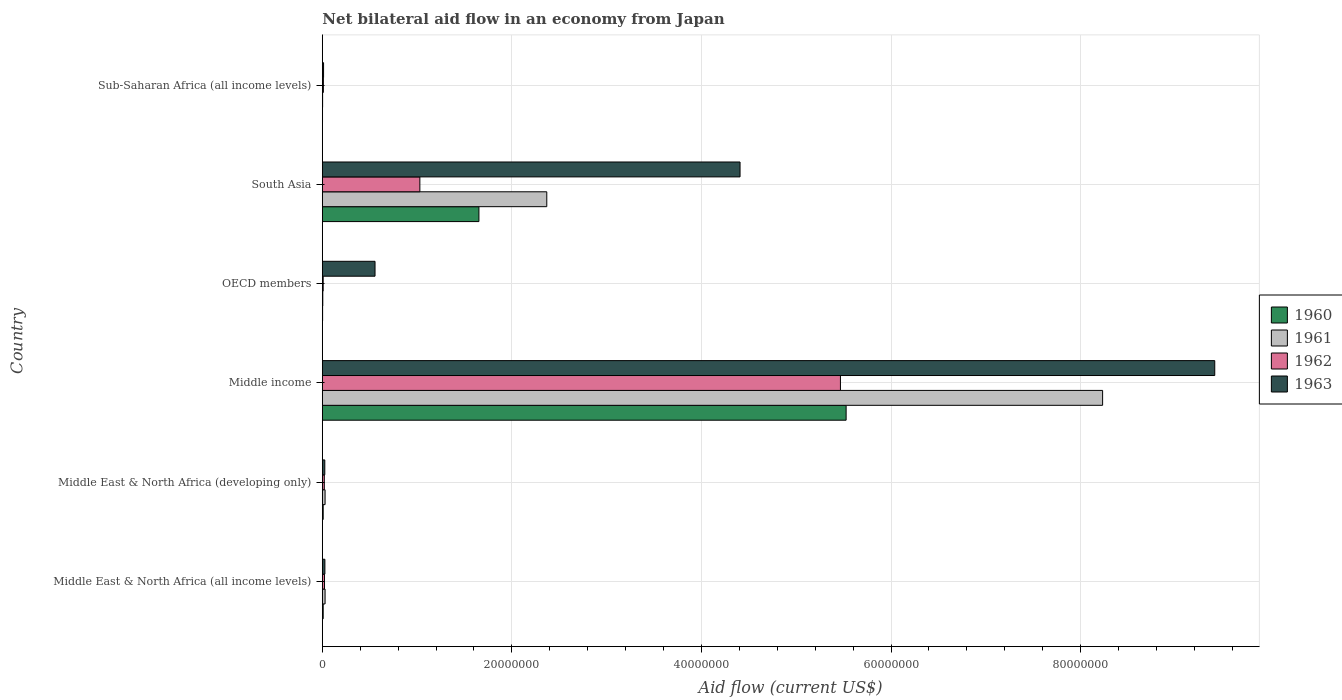How many different coloured bars are there?
Ensure brevity in your answer.  4. Are the number of bars per tick equal to the number of legend labels?
Your answer should be very brief. Yes. How many bars are there on the 6th tick from the top?
Ensure brevity in your answer.  4. How many bars are there on the 5th tick from the bottom?
Provide a short and direct response. 4. What is the net bilateral aid flow in 1963 in Middle East & North Africa (all income levels)?
Ensure brevity in your answer.  2.70e+05. Across all countries, what is the maximum net bilateral aid flow in 1962?
Provide a short and direct response. 5.47e+07. Across all countries, what is the minimum net bilateral aid flow in 1962?
Offer a very short reply. 9.00e+04. In which country was the net bilateral aid flow in 1960 minimum?
Offer a terse response. Sub-Saharan Africa (all income levels). What is the total net bilateral aid flow in 1960 in the graph?
Ensure brevity in your answer.  7.20e+07. What is the difference between the net bilateral aid flow in 1961 in South Asia and the net bilateral aid flow in 1960 in Middle East & North Africa (developing only)?
Offer a terse response. 2.36e+07. What is the average net bilateral aid flow in 1963 per country?
Provide a short and direct response. 2.41e+07. What is the difference between the net bilateral aid flow in 1961 and net bilateral aid flow in 1962 in South Asia?
Ensure brevity in your answer.  1.34e+07. In how many countries, is the net bilateral aid flow in 1960 greater than 92000000 US$?
Make the answer very short. 0. What is the ratio of the net bilateral aid flow in 1961 in Middle East & North Africa (developing only) to that in Middle income?
Provide a succinct answer. 0. Is the net bilateral aid flow in 1961 in OECD members less than that in Sub-Saharan Africa (all income levels)?
Offer a terse response. No. Is the difference between the net bilateral aid flow in 1961 in OECD members and Sub-Saharan Africa (all income levels) greater than the difference between the net bilateral aid flow in 1962 in OECD members and Sub-Saharan Africa (all income levels)?
Keep it short and to the point. Yes. What is the difference between the highest and the second highest net bilateral aid flow in 1960?
Offer a terse response. 3.87e+07. What is the difference between the highest and the lowest net bilateral aid flow in 1961?
Keep it short and to the point. 8.23e+07. In how many countries, is the net bilateral aid flow in 1963 greater than the average net bilateral aid flow in 1963 taken over all countries?
Your answer should be very brief. 2. Is the sum of the net bilateral aid flow in 1963 in Middle East & North Africa (all income levels) and Middle income greater than the maximum net bilateral aid flow in 1960 across all countries?
Offer a terse response. Yes. Is it the case that in every country, the sum of the net bilateral aid flow in 1960 and net bilateral aid flow in 1963 is greater than the sum of net bilateral aid flow in 1961 and net bilateral aid flow in 1962?
Your answer should be compact. No. What does the 2nd bar from the top in Middle East & North Africa (developing only) represents?
Keep it short and to the point. 1962. What does the 4th bar from the bottom in Middle income represents?
Offer a very short reply. 1963. How many bars are there?
Your answer should be very brief. 24. How many countries are there in the graph?
Offer a very short reply. 6. Does the graph contain grids?
Provide a succinct answer. Yes. Where does the legend appear in the graph?
Offer a terse response. Center right. How are the legend labels stacked?
Offer a terse response. Vertical. What is the title of the graph?
Offer a very short reply. Net bilateral aid flow in an economy from Japan. Does "2011" appear as one of the legend labels in the graph?
Your response must be concise. No. What is the Aid flow (current US$) of 1962 in Middle East & North Africa (all income levels)?
Provide a short and direct response. 2.30e+05. What is the Aid flow (current US$) of 1963 in Middle East & North Africa (all income levels)?
Give a very brief answer. 2.70e+05. What is the Aid flow (current US$) in 1961 in Middle East & North Africa (developing only)?
Keep it short and to the point. 2.90e+05. What is the Aid flow (current US$) in 1962 in Middle East & North Africa (developing only)?
Keep it short and to the point. 2.10e+05. What is the Aid flow (current US$) of 1963 in Middle East & North Africa (developing only)?
Provide a succinct answer. 2.60e+05. What is the Aid flow (current US$) in 1960 in Middle income?
Provide a short and direct response. 5.53e+07. What is the Aid flow (current US$) in 1961 in Middle income?
Your answer should be compact. 8.23e+07. What is the Aid flow (current US$) of 1962 in Middle income?
Provide a succinct answer. 5.47e+07. What is the Aid flow (current US$) of 1963 in Middle income?
Offer a terse response. 9.42e+07. What is the Aid flow (current US$) in 1960 in OECD members?
Offer a very short reply. 3.00e+04. What is the Aid flow (current US$) in 1962 in OECD members?
Give a very brief answer. 9.00e+04. What is the Aid flow (current US$) of 1963 in OECD members?
Offer a terse response. 5.56e+06. What is the Aid flow (current US$) of 1960 in South Asia?
Provide a succinct answer. 1.65e+07. What is the Aid flow (current US$) in 1961 in South Asia?
Your answer should be compact. 2.37e+07. What is the Aid flow (current US$) of 1962 in South Asia?
Provide a succinct answer. 1.03e+07. What is the Aid flow (current US$) in 1963 in South Asia?
Your answer should be compact. 4.41e+07. What is the Aid flow (current US$) of 1961 in Sub-Saharan Africa (all income levels)?
Your response must be concise. 3.00e+04. What is the Aid flow (current US$) of 1962 in Sub-Saharan Africa (all income levels)?
Your response must be concise. 1.10e+05. What is the Aid flow (current US$) in 1963 in Sub-Saharan Africa (all income levels)?
Keep it short and to the point. 1.30e+05. Across all countries, what is the maximum Aid flow (current US$) of 1960?
Your response must be concise. 5.53e+07. Across all countries, what is the maximum Aid flow (current US$) of 1961?
Make the answer very short. 8.23e+07. Across all countries, what is the maximum Aid flow (current US$) in 1962?
Your response must be concise. 5.47e+07. Across all countries, what is the maximum Aid flow (current US$) of 1963?
Your response must be concise. 9.42e+07. Across all countries, what is the minimum Aid flow (current US$) in 1961?
Keep it short and to the point. 3.00e+04. Across all countries, what is the minimum Aid flow (current US$) of 1962?
Ensure brevity in your answer.  9.00e+04. Across all countries, what is the minimum Aid flow (current US$) in 1963?
Give a very brief answer. 1.30e+05. What is the total Aid flow (current US$) of 1960 in the graph?
Your answer should be very brief. 7.20e+07. What is the total Aid flow (current US$) of 1961 in the graph?
Give a very brief answer. 1.07e+08. What is the total Aid flow (current US$) of 1962 in the graph?
Offer a very short reply. 6.56e+07. What is the total Aid flow (current US$) in 1963 in the graph?
Your answer should be very brief. 1.44e+08. What is the difference between the Aid flow (current US$) in 1961 in Middle East & North Africa (all income levels) and that in Middle East & North Africa (developing only)?
Ensure brevity in your answer.  0. What is the difference between the Aid flow (current US$) in 1962 in Middle East & North Africa (all income levels) and that in Middle East & North Africa (developing only)?
Give a very brief answer. 2.00e+04. What is the difference between the Aid flow (current US$) in 1960 in Middle East & North Africa (all income levels) and that in Middle income?
Provide a short and direct response. -5.52e+07. What is the difference between the Aid flow (current US$) in 1961 in Middle East & North Africa (all income levels) and that in Middle income?
Offer a very short reply. -8.20e+07. What is the difference between the Aid flow (current US$) of 1962 in Middle East & North Africa (all income levels) and that in Middle income?
Provide a succinct answer. -5.44e+07. What is the difference between the Aid flow (current US$) of 1963 in Middle East & North Africa (all income levels) and that in Middle income?
Keep it short and to the point. -9.39e+07. What is the difference between the Aid flow (current US$) in 1962 in Middle East & North Africa (all income levels) and that in OECD members?
Provide a short and direct response. 1.40e+05. What is the difference between the Aid flow (current US$) in 1963 in Middle East & North Africa (all income levels) and that in OECD members?
Your response must be concise. -5.29e+06. What is the difference between the Aid flow (current US$) in 1960 in Middle East & North Africa (all income levels) and that in South Asia?
Offer a terse response. -1.64e+07. What is the difference between the Aid flow (current US$) of 1961 in Middle East & North Africa (all income levels) and that in South Asia?
Offer a terse response. -2.34e+07. What is the difference between the Aid flow (current US$) in 1962 in Middle East & North Africa (all income levels) and that in South Asia?
Offer a very short reply. -1.01e+07. What is the difference between the Aid flow (current US$) in 1963 in Middle East & North Africa (all income levels) and that in South Asia?
Offer a very short reply. -4.38e+07. What is the difference between the Aid flow (current US$) in 1961 in Middle East & North Africa (all income levels) and that in Sub-Saharan Africa (all income levels)?
Ensure brevity in your answer.  2.60e+05. What is the difference between the Aid flow (current US$) in 1963 in Middle East & North Africa (all income levels) and that in Sub-Saharan Africa (all income levels)?
Keep it short and to the point. 1.40e+05. What is the difference between the Aid flow (current US$) of 1960 in Middle East & North Africa (developing only) and that in Middle income?
Your answer should be compact. -5.52e+07. What is the difference between the Aid flow (current US$) in 1961 in Middle East & North Africa (developing only) and that in Middle income?
Your response must be concise. -8.20e+07. What is the difference between the Aid flow (current US$) of 1962 in Middle East & North Africa (developing only) and that in Middle income?
Your answer should be very brief. -5.44e+07. What is the difference between the Aid flow (current US$) of 1963 in Middle East & North Africa (developing only) and that in Middle income?
Give a very brief answer. -9.39e+07. What is the difference between the Aid flow (current US$) in 1960 in Middle East & North Africa (developing only) and that in OECD members?
Keep it short and to the point. 6.00e+04. What is the difference between the Aid flow (current US$) in 1961 in Middle East & North Africa (developing only) and that in OECD members?
Your response must be concise. 2.40e+05. What is the difference between the Aid flow (current US$) in 1962 in Middle East & North Africa (developing only) and that in OECD members?
Your answer should be very brief. 1.20e+05. What is the difference between the Aid flow (current US$) in 1963 in Middle East & North Africa (developing only) and that in OECD members?
Provide a succinct answer. -5.30e+06. What is the difference between the Aid flow (current US$) in 1960 in Middle East & North Africa (developing only) and that in South Asia?
Make the answer very short. -1.64e+07. What is the difference between the Aid flow (current US$) of 1961 in Middle East & North Africa (developing only) and that in South Asia?
Your response must be concise. -2.34e+07. What is the difference between the Aid flow (current US$) of 1962 in Middle East & North Africa (developing only) and that in South Asia?
Your answer should be very brief. -1.01e+07. What is the difference between the Aid flow (current US$) of 1963 in Middle East & North Africa (developing only) and that in South Asia?
Provide a succinct answer. -4.38e+07. What is the difference between the Aid flow (current US$) of 1961 in Middle East & North Africa (developing only) and that in Sub-Saharan Africa (all income levels)?
Your response must be concise. 2.60e+05. What is the difference between the Aid flow (current US$) of 1962 in Middle East & North Africa (developing only) and that in Sub-Saharan Africa (all income levels)?
Your answer should be very brief. 1.00e+05. What is the difference between the Aid flow (current US$) of 1960 in Middle income and that in OECD members?
Your response must be concise. 5.52e+07. What is the difference between the Aid flow (current US$) of 1961 in Middle income and that in OECD members?
Ensure brevity in your answer.  8.23e+07. What is the difference between the Aid flow (current US$) of 1962 in Middle income and that in OECD members?
Keep it short and to the point. 5.46e+07. What is the difference between the Aid flow (current US$) in 1963 in Middle income and that in OECD members?
Keep it short and to the point. 8.86e+07. What is the difference between the Aid flow (current US$) of 1960 in Middle income and that in South Asia?
Ensure brevity in your answer.  3.87e+07. What is the difference between the Aid flow (current US$) in 1961 in Middle income and that in South Asia?
Ensure brevity in your answer.  5.86e+07. What is the difference between the Aid flow (current US$) of 1962 in Middle income and that in South Asia?
Provide a short and direct response. 4.44e+07. What is the difference between the Aid flow (current US$) in 1963 in Middle income and that in South Asia?
Your answer should be compact. 5.01e+07. What is the difference between the Aid flow (current US$) in 1960 in Middle income and that in Sub-Saharan Africa (all income levels)?
Your response must be concise. 5.52e+07. What is the difference between the Aid flow (current US$) in 1961 in Middle income and that in Sub-Saharan Africa (all income levels)?
Ensure brevity in your answer.  8.23e+07. What is the difference between the Aid flow (current US$) in 1962 in Middle income and that in Sub-Saharan Africa (all income levels)?
Offer a terse response. 5.46e+07. What is the difference between the Aid flow (current US$) of 1963 in Middle income and that in Sub-Saharan Africa (all income levels)?
Offer a terse response. 9.40e+07. What is the difference between the Aid flow (current US$) in 1960 in OECD members and that in South Asia?
Provide a short and direct response. -1.65e+07. What is the difference between the Aid flow (current US$) of 1961 in OECD members and that in South Asia?
Ensure brevity in your answer.  -2.36e+07. What is the difference between the Aid flow (current US$) in 1962 in OECD members and that in South Asia?
Your answer should be very brief. -1.02e+07. What is the difference between the Aid flow (current US$) of 1963 in OECD members and that in South Asia?
Provide a short and direct response. -3.85e+07. What is the difference between the Aid flow (current US$) in 1960 in OECD members and that in Sub-Saharan Africa (all income levels)?
Ensure brevity in your answer.  10000. What is the difference between the Aid flow (current US$) in 1961 in OECD members and that in Sub-Saharan Africa (all income levels)?
Ensure brevity in your answer.  2.00e+04. What is the difference between the Aid flow (current US$) of 1962 in OECD members and that in Sub-Saharan Africa (all income levels)?
Make the answer very short. -2.00e+04. What is the difference between the Aid flow (current US$) in 1963 in OECD members and that in Sub-Saharan Africa (all income levels)?
Provide a short and direct response. 5.43e+06. What is the difference between the Aid flow (current US$) of 1960 in South Asia and that in Sub-Saharan Africa (all income levels)?
Provide a succinct answer. 1.65e+07. What is the difference between the Aid flow (current US$) of 1961 in South Asia and that in Sub-Saharan Africa (all income levels)?
Your answer should be very brief. 2.36e+07. What is the difference between the Aid flow (current US$) of 1962 in South Asia and that in Sub-Saharan Africa (all income levels)?
Provide a succinct answer. 1.02e+07. What is the difference between the Aid flow (current US$) in 1963 in South Asia and that in Sub-Saharan Africa (all income levels)?
Your answer should be compact. 4.39e+07. What is the difference between the Aid flow (current US$) of 1960 in Middle East & North Africa (all income levels) and the Aid flow (current US$) of 1961 in Middle East & North Africa (developing only)?
Ensure brevity in your answer.  -2.00e+05. What is the difference between the Aid flow (current US$) of 1960 in Middle East & North Africa (all income levels) and the Aid flow (current US$) of 1962 in Middle East & North Africa (developing only)?
Your answer should be compact. -1.20e+05. What is the difference between the Aid flow (current US$) of 1961 in Middle East & North Africa (all income levels) and the Aid flow (current US$) of 1962 in Middle East & North Africa (developing only)?
Offer a very short reply. 8.00e+04. What is the difference between the Aid flow (current US$) of 1960 in Middle East & North Africa (all income levels) and the Aid flow (current US$) of 1961 in Middle income?
Keep it short and to the point. -8.22e+07. What is the difference between the Aid flow (current US$) in 1960 in Middle East & North Africa (all income levels) and the Aid flow (current US$) in 1962 in Middle income?
Offer a terse response. -5.46e+07. What is the difference between the Aid flow (current US$) in 1960 in Middle East & North Africa (all income levels) and the Aid flow (current US$) in 1963 in Middle income?
Provide a short and direct response. -9.41e+07. What is the difference between the Aid flow (current US$) in 1961 in Middle East & North Africa (all income levels) and the Aid flow (current US$) in 1962 in Middle income?
Your answer should be compact. -5.44e+07. What is the difference between the Aid flow (current US$) in 1961 in Middle East & North Africa (all income levels) and the Aid flow (current US$) in 1963 in Middle income?
Your response must be concise. -9.39e+07. What is the difference between the Aid flow (current US$) in 1962 in Middle East & North Africa (all income levels) and the Aid flow (current US$) in 1963 in Middle income?
Offer a terse response. -9.39e+07. What is the difference between the Aid flow (current US$) of 1960 in Middle East & North Africa (all income levels) and the Aid flow (current US$) of 1961 in OECD members?
Your answer should be compact. 4.00e+04. What is the difference between the Aid flow (current US$) of 1960 in Middle East & North Africa (all income levels) and the Aid flow (current US$) of 1962 in OECD members?
Your answer should be compact. 0. What is the difference between the Aid flow (current US$) in 1960 in Middle East & North Africa (all income levels) and the Aid flow (current US$) in 1963 in OECD members?
Your response must be concise. -5.47e+06. What is the difference between the Aid flow (current US$) in 1961 in Middle East & North Africa (all income levels) and the Aid flow (current US$) in 1963 in OECD members?
Provide a succinct answer. -5.27e+06. What is the difference between the Aid flow (current US$) in 1962 in Middle East & North Africa (all income levels) and the Aid flow (current US$) in 1963 in OECD members?
Provide a short and direct response. -5.33e+06. What is the difference between the Aid flow (current US$) of 1960 in Middle East & North Africa (all income levels) and the Aid flow (current US$) of 1961 in South Asia?
Provide a short and direct response. -2.36e+07. What is the difference between the Aid flow (current US$) in 1960 in Middle East & North Africa (all income levels) and the Aid flow (current US$) in 1962 in South Asia?
Provide a succinct answer. -1.02e+07. What is the difference between the Aid flow (current US$) in 1960 in Middle East & North Africa (all income levels) and the Aid flow (current US$) in 1963 in South Asia?
Offer a terse response. -4.40e+07. What is the difference between the Aid flow (current US$) in 1961 in Middle East & North Africa (all income levels) and the Aid flow (current US$) in 1962 in South Asia?
Ensure brevity in your answer.  -1.00e+07. What is the difference between the Aid flow (current US$) of 1961 in Middle East & North Africa (all income levels) and the Aid flow (current US$) of 1963 in South Asia?
Your answer should be compact. -4.38e+07. What is the difference between the Aid flow (current US$) in 1962 in Middle East & North Africa (all income levels) and the Aid flow (current US$) in 1963 in South Asia?
Give a very brief answer. -4.38e+07. What is the difference between the Aid flow (current US$) in 1960 in Middle East & North Africa (all income levels) and the Aid flow (current US$) in 1962 in Sub-Saharan Africa (all income levels)?
Offer a terse response. -2.00e+04. What is the difference between the Aid flow (current US$) of 1960 in Middle East & North Africa (developing only) and the Aid flow (current US$) of 1961 in Middle income?
Provide a succinct answer. -8.22e+07. What is the difference between the Aid flow (current US$) of 1960 in Middle East & North Africa (developing only) and the Aid flow (current US$) of 1962 in Middle income?
Keep it short and to the point. -5.46e+07. What is the difference between the Aid flow (current US$) of 1960 in Middle East & North Africa (developing only) and the Aid flow (current US$) of 1963 in Middle income?
Offer a terse response. -9.41e+07. What is the difference between the Aid flow (current US$) in 1961 in Middle East & North Africa (developing only) and the Aid flow (current US$) in 1962 in Middle income?
Make the answer very short. -5.44e+07. What is the difference between the Aid flow (current US$) in 1961 in Middle East & North Africa (developing only) and the Aid flow (current US$) in 1963 in Middle income?
Give a very brief answer. -9.39e+07. What is the difference between the Aid flow (current US$) of 1962 in Middle East & North Africa (developing only) and the Aid flow (current US$) of 1963 in Middle income?
Your response must be concise. -9.39e+07. What is the difference between the Aid flow (current US$) of 1960 in Middle East & North Africa (developing only) and the Aid flow (current US$) of 1962 in OECD members?
Give a very brief answer. 0. What is the difference between the Aid flow (current US$) in 1960 in Middle East & North Africa (developing only) and the Aid flow (current US$) in 1963 in OECD members?
Give a very brief answer. -5.47e+06. What is the difference between the Aid flow (current US$) in 1961 in Middle East & North Africa (developing only) and the Aid flow (current US$) in 1963 in OECD members?
Ensure brevity in your answer.  -5.27e+06. What is the difference between the Aid flow (current US$) in 1962 in Middle East & North Africa (developing only) and the Aid flow (current US$) in 1963 in OECD members?
Give a very brief answer. -5.35e+06. What is the difference between the Aid flow (current US$) of 1960 in Middle East & North Africa (developing only) and the Aid flow (current US$) of 1961 in South Asia?
Your response must be concise. -2.36e+07. What is the difference between the Aid flow (current US$) of 1960 in Middle East & North Africa (developing only) and the Aid flow (current US$) of 1962 in South Asia?
Ensure brevity in your answer.  -1.02e+07. What is the difference between the Aid flow (current US$) of 1960 in Middle East & North Africa (developing only) and the Aid flow (current US$) of 1963 in South Asia?
Ensure brevity in your answer.  -4.40e+07. What is the difference between the Aid flow (current US$) in 1961 in Middle East & North Africa (developing only) and the Aid flow (current US$) in 1962 in South Asia?
Offer a terse response. -1.00e+07. What is the difference between the Aid flow (current US$) in 1961 in Middle East & North Africa (developing only) and the Aid flow (current US$) in 1963 in South Asia?
Ensure brevity in your answer.  -4.38e+07. What is the difference between the Aid flow (current US$) in 1962 in Middle East & North Africa (developing only) and the Aid flow (current US$) in 1963 in South Asia?
Your answer should be very brief. -4.39e+07. What is the difference between the Aid flow (current US$) of 1960 in Middle East & North Africa (developing only) and the Aid flow (current US$) of 1961 in Sub-Saharan Africa (all income levels)?
Your answer should be compact. 6.00e+04. What is the difference between the Aid flow (current US$) of 1960 in Middle East & North Africa (developing only) and the Aid flow (current US$) of 1963 in Sub-Saharan Africa (all income levels)?
Offer a terse response. -4.00e+04. What is the difference between the Aid flow (current US$) of 1961 in Middle East & North Africa (developing only) and the Aid flow (current US$) of 1962 in Sub-Saharan Africa (all income levels)?
Give a very brief answer. 1.80e+05. What is the difference between the Aid flow (current US$) in 1962 in Middle East & North Africa (developing only) and the Aid flow (current US$) in 1963 in Sub-Saharan Africa (all income levels)?
Your answer should be very brief. 8.00e+04. What is the difference between the Aid flow (current US$) in 1960 in Middle income and the Aid flow (current US$) in 1961 in OECD members?
Give a very brief answer. 5.52e+07. What is the difference between the Aid flow (current US$) of 1960 in Middle income and the Aid flow (current US$) of 1962 in OECD members?
Offer a terse response. 5.52e+07. What is the difference between the Aid flow (current US$) in 1960 in Middle income and the Aid flow (current US$) in 1963 in OECD members?
Provide a short and direct response. 4.97e+07. What is the difference between the Aid flow (current US$) of 1961 in Middle income and the Aid flow (current US$) of 1962 in OECD members?
Your response must be concise. 8.22e+07. What is the difference between the Aid flow (current US$) of 1961 in Middle income and the Aid flow (current US$) of 1963 in OECD members?
Give a very brief answer. 7.68e+07. What is the difference between the Aid flow (current US$) of 1962 in Middle income and the Aid flow (current US$) of 1963 in OECD members?
Offer a terse response. 4.91e+07. What is the difference between the Aid flow (current US$) of 1960 in Middle income and the Aid flow (current US$) of 1961 in South Asia?
Your answer should be compact. 3.16e+07. What is the difference between the Aid flow (current US$) of 1960 in Middle income and the Aid flow (current US$) of 1962 in South Asia?
Offer a very short reply. 4.50e+07. What is the difference between the Aid flow (current US$) of 1960 in Middle income and the Aid flow (current US$) of 1963 in South Asia?
Keep it short and to the point. 1.12e+07. What is the difference between the Aid flow (current US$) in 1961 in Middle income and the Aid flow (current US$) in 1962 in South Asia?
Offer a terse response. 7.20e+07. What is the difference between the Aid flow (current US$) of 1961 in Middle income and the Aid flow (current US$) of 1963 in South Asia?
Your answer should be compact. 3.82e+07. What is the difference between the Aid flow (current US$) of 1962 in Middle income and the Aid flow (current US$) of 1963 in South Asia?
Provide a succinct answer. 1.06e+07. What is the difference between the Aid flow (current US$) of 1960 in Middle income and the Aid flow (current US$) of 1961 in Sub-Saharan Africa (all income levels)?
Make the answer very short. 5.52e+07. What is the difference between the Aid flow (current US$) of 1960 in Middle income and the Aid flow (current US$) of 1962 in Sub-Saharan Africa (all income levels)?
Your answer should be very brief. 5.52e+07. What is the difference between the Aid flow (current US$) in 1960 in Middle income and the Aid flow (current US$) in 1963 in Sub-Saharan Africa (all income levels)?
Provide a succinct answer. 5.51e+07. What is the difference between the Aid flow (current US$) in 1961 in Middle income and the Aid flow (current US$) in 1962 in Sub-Saharan Africa (all income levels)?
Keep it short and to the point. 8.22e+07. What is the difference between the Aid flow (current US$) of 1961 in Middle income and the Aid flow (current US$) of 1963 in Sub-Saharan Africa (all income levels)?
Provide a short and direct response. 8.22e+07. What is the difference between the Aid flow (current US$) in 1962 in Middle income and the Aid flow (current US$) in 1963 in Sub-Saharan Africa (all income levels)?
Provide a succinct answer. 5.45e+07. What is the difference between the Aid flow (current US$) of 1960 in OECD members and the Aid flow (current US$) of 1961 in South Asia?
Provide a short and direct response. -2.36e+07. What is the difference between the Aid flow (current US$) of 1960 in OECD members and the Aid flow (current US$) of 1962 in South Asia?
Provide a succinct answer. -1.03e+07. What is the difference between the Aid flow (current US$) in 1960 in OECD members and the Aid flow (current US$) in 1963 in South Asia?
Your answer should be very brief. -4.40e+07. What is the difference between the Aid flow (current US$) in 1961 in OECD members and the Aid flow (current US$) in 1962 in South Asia?
Your answer should be very brief. -1.02e+07. What is the difference between the Aid flow (current US$) of 1961 in OECD members and the Aid flow (current US$) of 1963 in South Asia?
Make the answer very short. -4.40e+07. What is the difference between the Aid flow (current US$) of 1962 in OECD members and the Aid flow (current US$) of 1963 in South Asia?
Make the answer very short. -4.40e+07. What is the difference between the Aid flow (current US$) in 1960 in OECD members and the Aid flow (current US$) in 1961 in Sub-Saharan Africa (all income levels)?
Keep it short and to the point. 0. What is the difference between the Aid flow (current US$) in 1962 in OECD members and the Aid flow (current US$) in 1963 in Sub-Saharan Africa (all income levels)?
Keep it short and to the point. -4.00e+04. What is the difference between the Aid flow (current US$) of 1960 in South Asia and the Aid flow (current US$) of 1961 in Sub-Saharan Africa (all income levels)?
Offer a very short reply. 1.65e+07. What is the difference between the Aid flow (current US$) of 1960 in South Asia and the Aid flow (current US$) of 1962 in Sub-Saharan Africa (all income levels)?
Provide a succinct answer. 1.64e+07. What is the difference between the Aid flow (current US$) of 1960 in South Asia and the Aid flow (current US$) of 1963 in Sub-Saharan Africa (all income levels)?
Ensure brevity in your answer.  1.64e+07. What is the difference between the Aid flow (current US$) of 1961 in South Asia and the Aid flow (current US$) of 1962 in Sub-Saharan Africa (all income levels)?
Offer a terse response. 2.36e+07. What is the difference between the Aid flow (current US$) in 1961 in South Asia and the Aid flow (current US$) in 1963 in Sub-Saharan Africa (all income levels)?
Your answer should be very brief. 2.36e+07. What is the difference between the Aid flow (current US$) in 1962 in South Asia and the Aid flow (current US$) in 1963 in Sub-Saharan Africa (all income levels)?
Give a very brief answer. 1.02e+07. What is the average Aid flow (current US$) in 1960 per country?
Ensure brevity in your answer.  1.20e+07. What is the average Aid flow (current US$) of 1961 per country?
Provide a short and direct response. 1.78e+07. What is the average Aid flow (current US$) in 1962 per country?
Your answer should be compact. 1.09e+07. What is the average Aid flow (current US$) in 1963 per country?
Offer a terse response. 2.41e+07. What is the difference between the Aid flow (current US$) in 1961 and Aid flow (current US$) in 1962 in Middle East & North Africa (all income levels)?
Offer a terse response. 6.00e+04. What is the difference between the Aid flow (current US$) of 1961 and Aid flow (current US$) of 1963 in Middle East & North Africa (all income levels)?
Offer a terse response. 2.00e+04. What is the difference between the Aid flow (current US$) of 1962 and Aid flow (current US$) of 1963 in Middle East & North Africa (all income levels)?
Give a very brief answer. -4.00e+04. What is the difference between the Aid flow (current US$) in 1960 and Aid flow (current US$) in 1961 in Middle East & North Africa (developing only)?
Provide a short and direct response. -2.00e+05. What is the difference between the Aid flow (current US$) of 1961 and Aid flow (current US$) of 1963 in Middle East & North Africa (developing only)?
Offer a very short reply. 3.00e+04. What is the difference between the Aid flow (current US$) in 1962 and Aid flow (current US$) in 1963 in Middle East & North Africa (developing only)?
Provide a succinct answer. -5.00e+04. What is the difference between the Aid flow (current US$) of 1960 and Aid flow (current US$) of 1961 in Middle income?
Keep it short and to the point. -2.71e+07. What is the difference between the Aid flow (current US$) of 1960 and Aid flow (current US$) of 1962 in Middle income?
Keep it short and to the point. 6.00e+05. What is the difference between the Aid flow (current US$) in 1960 and Aid flow (current US$) in 1963 in Middle income?
Your answer should be very brief. -3.89e+07. What is the difference between the Aid flow (current US$) in 1961 and Aid flow (current US$) in 1962 in Middle income?
Provide a succinct answer. 2.77e+07. What is the difference between the Aid flow (current US$) in 1961 and Aid flow (current US$) in 1963 in Middle income?
Provide a short and direct response. -1.18e+07. What is the difference between the Aid flow (current US$) in 1962 and Aid flow (current US$) in 1963 in Middle income?
Provide a succinct answer. -3.95e+07. What is the difference between the Aid flow (current US$) in 1960 and Aid flow (current US$) in 1961 in OECD members?
Your response must be concise. -2.00e+04. What is the difference between the Aid flow (current US$) of 1960 and Aid flow (current US$) of 1962 in OECD members?
Provide a succinct answer. -6.00e+04. What is the difference between the Aid flow (current US$) of 1960 and Aid flow (current US$) of 1963 in OECD members?
Ensure brevity in your answer.  -5.53e+06. What is the difference between the Aid flow (current US$) of 1961 and Aid flow (current US$) of 1963 in OECD members?
Keep it short and to the point. -5.51e+06. What is the difference between the Aid flow (current US$) of 1962 and Aid flow (current US$) of 1963 in OECD members?
Keep it short and to the point. -5.47e+06. What is the difference between the Aid flow (current US$) of 1960 and Aid flow (current US$) of 1961 in South Asia?
Your answer should be compact. -7.16e+06. What is the difference between the Aid flow (current US$) in 1960 and Aid flow (current US$) in 1962 in South Asia?
Your answer should be very brief. 6.23e+06. What is the difference between the Aid flow (current US$) of 1960 and Aid flow (current US$) of 1963 in South Asia?
Offer a terse response. -2.76e+07. What is the difference between the Aid flow (current US$) of 1961 and Aid flow (current US$) of 1962 in South Asia?
Offer a terse response. 1.34e+07. What is the difference between the Aid flow (current US$) in 1961 and Aid flow (current US$) in 1963 in South Asia?
Keep it short and to the point. -2.04e+07. What is the difference between the Aid flow (current US$) of 1962 and Aid flow (current US$) of 1963 in South Asia?
Keep it short and to the point. -3.38e+07. What is the difference between the Aid flow (current US$) of 1960 and Aid flow (current US$) of 1963 in Sub-Saharan Africa (all income levels)?
Keep it short and to the point. -1.10e+05. What is the difference between the Aid flow (current US$) in 1961 and Aid flow (current US$) in 1962 in Sub-Saharan Africa (all income levels)?
Your response must be concise. -8.00e+04. What is the difference between the Aid flow (current US$) in 1961 and Aid flow (current US$) in 1963 in Sub-Saharan Africa (all income levels)?
Keep it short and to the point. -1.00e+05. What is the difference between the Aid flow (current US$) in 1962 and Aid flow (current US$) in 1963 in Sub-Saharan Africa (all income levels)?
Offer a terse response. -2.00e+04. What is the ratio of the Aid flow (current US$) of 1961 in Middle East & North Africa (all income levels) to that in Middle East & North Africa (developing only)?
Provide a short and direct response. 1. What is the ratio of the Aid flow (current US$) in 1962 in Middle East & North Africa (all income levels) to that in Middle East & North Africa (developing only)?
Provide a short and direct response. 1.1. What is the ratio of the Aid flow (current US$) in 1960 in Middle East & North Africa (all income levels) to that in Middle income?
Provide a short and direct response. 0. What is the ratio of the Aid flow (current US$) of 1961 in Middle East & North Africa (all income levels) to that in Middle income?
Offer a very short reply. 0. What is the ratio of the Aid flow (current US$) in 1962 in Middle East & North Africa (all income levels) to that in Middle income?
Your answer should be compact. 0. What is the ratio of the Aid flow (current US$) of 1963 in Middle East & North Africa (all income levels) to that in Middle income?
Your response must be concise. 0. What is the ratio of the Aid flow (current US$) in 1960 in Middle East & North Africa (all income levels) to that in OECD members?
Provide a short and direct response. 3. What is the ratio of the Aid flow (current US$) in 1962 in Middle East & North Africa (all income levels) to that in OECD members?
Offer a very short reply. 2.56. What is the ratio of the Aid flow (current US$) of 1963 in Middle East & North Africa (all income levels) to that in OECD members?
Provide a succinct answer. 0.05. What is the ratio of the Aid flow (current US$) in 1960 in Middle East & North Africa (all income levels) to that in South Asia?
Provide a short and direct response. 0.01. What is the ratio of the Aid flow (current US$) in 1961 in Middle East & North Africa (all income levels) to that in South Asia?
Make the answer very short. 0.01. What is the ratio of the Aid flow (current US$) of 1962 in Middle East & North Africa (all income levels) to that in South Asia?
Offer a terse response. 0.02. What is the ratio of the Aid flow (current US$) of 1963 in Middle East & North Africa (all income levels) to that in South Asia?
Offer a very short reply. 0.01. What is the ratio of the Aid flow (current US$) of 1960 in Middle East & North Africa (all income levels) to that in Sub-Saharan Africa (all income levels)?
Provide a succinct answer. 4.5. What is the ratio of the Aid flow (current US$) in 1961 in Middle East & North Africa (all income levels) to that in Sub-Saharan Africa (all income levels)?
Your answer should be compact. 9.67. What is the ratio of the Aid flow (current US$) of 1962 in Middle East & North Africa (all income levels) to that in Sub-Saharan Africa (all income levels)?
Provide a succinct answer. 2.09. What is the ratio of the Aid flow (current US$) in 1963 in Middle East & North Africa (all income levels) to that in Sub-Saharan Africa (all income levels)?
Keep it short and to the point. 2.08. What is the ratio of the Aid flow (current US$) of 1960 in Middle East & North Africa (developing only) to that in Middle income?
Give a very brief answer. 0. What is the ratio of the Aid flow (current US$) in 1961 in Middle East & North Africa (developing only) to that in Middle income?
Give a very brief answer. 0. What is the ratio of the Aid flow (current US$) in 1962 in Middle East & North Africa (developing only) to that in Middle income?
Ensure brevity in your answer.  0. What is the ratio of the Aid flow (current US$) in 1963 in Middle East & North Africa (developing only) to that in Middle income?
Your response must be concise. 0. What is the ratio of the Aid flow (current US$) of 1960 in Middle East & North Africa (developing only) to that in OECD members?
Your answer should be compact. 3. What is the ratio of the Aid flow (current US$) of 1961 in Middle East & North Africa (developing only) to that in OECD members?
Offer a very short reply. 5.8. What is the ratio of the Aid flow (current US$) in 1962 in Middle East & North Africa (developing only) to that in OECD members?
Offer a very short reply. 2.33. What is the ratio of the Aid flow (current US$) in 1963 in Middle East & North Africa (developing only) to that in OECD members?
Keep it short and to the point. 0.05. What is the ratio of the Aid flow (current US$) in 1960 in Middle East & North Africa (developing only) to that in South Asia?
Provide a succinct answer. 0.01. What is the ratio of the Aid flow (current US$) of 1961 in Middle East & North Africa (developing only) to that in South Asia?
Your response must be concise. 0.01. What is the ratio of the Aid flow (current US$) in 1962 in Middle East & North Africa (developing only) to that in South Asia?
Offer a terse response. 0.02. What is the ratio of the Aid flow (current US$) of 1963 in Middle East & North Africa (developing only) to that in South Asia?
Offer a terse response. 0.01. What is the ratio of the Aid flow (current US$) in 1960 in Middle East & North Africa (developing only) to that in Sub-Saharan Africa (all income levels)?
Keep it short and to the point. 4.5. What is the ratio of the Aid flow (current US$) in 1961 in Middle East & North Africa (developing only) to that in Sub-Saharan Africa (all income levels)?
Make the answer very short. 9.67. What is the ratio of the Aid flow (current US$) in 1962 in Middle East & North Africa (developing only) to that in Sub-Saharan Africa (all income levels)?
Make the answer very short. 1.91. What is the ratio of the Aid flow (current US$) of 1960 in Middle income to that in OECD members?
Offer a very short reply. 1842. What is the ratio of the Aid flow (current US$) of 1961 in Middle income to that in OECD members?
Provide a short and direct response. 1646.4. What is the ratio of the Aid flow (current US$) of 1962 in Middle income to that in OECD members?
Your response must be concise. 607.33. What is the ratio of the Aid flow (current US$) in 1963 in Middle income to that in OECD members?
Your answer should be compact. 16.93. What is the ratio of the Aid flow (current US$) of 1960 in Middle income to that in South Asia?
Offer a very short reply. 3.35. What is the ratio of the Aid flow (current US$) in 1961 in Middle income to that in South Asia?
Your answer should be very brief. 3.48. What is the ratio of the Aid flow (current US$) of 1962 in Middle income to that in South Asia?
Your answer should be compact. 5.31. What is the ratio of the Aid flow (current US$) of 1963 in Middle income to that in South Asia?
Offer a very short reply. 2.14. What is the ratio of the Aid flow (current US$) of 1960 in Middle income to that in Sub-Saharan Africa (all income levels)?
Keep it short and to the point. 2763. What is the ratio of the Aid flow (current US$) in 1961 in Middle income to that in Sub-Saharan Africa (all income levels)?
Your response must be concise. 2744. What is the ratio of the Aid flow (current US$) of 1962 in Middle income to that in Sub-Saharan Africa (all income levels)?
Give a very brief answer. 496.91. What is the ratio of the Aid flow (current US$) in 1963 in Middle income to that in Sub-Saharan Africa (all income levels)?
Your answer should be compact. 724.23. What is the ratio of the Aid flow (current US$) in 1960 in OECD members to that in South Asia?
Your answer should be very brief. 0. What is the ratio of the Aid flow (current US$) of 1961 in OECD members to that in South Asia?
Your answer should be very brief. 0. What is the ratio of the Aid flow (current US$) of 1962 in OECD members to that in South Asia?
Offer a very short reply. 0.01. What is the ratio of the Aid flow (current US$) in 1963 in OECD members to that in South Asia?
Offer a very short reply. 0.13. What is the ratio of the Aid flow (current US$) of 1960 in OECD members to that in Sub-Saharan Africa (all income levels)?
Your answer should be very brief. 1.5. What is the ratio of the Aid flow (current US$) of 1962 in OECD members to that in Sub-Saharan Africa (all income levels)?
Provide a short and direct response. 0.82. What is the ratio of the Aid flow (current US$) of 1963 in OECD members to that in Sub-Saharan Africa (all income levels)?
Your response must be concise. 42.77. What is the ratio of the Aid flow (current US$) in 1960 in South Asia to that in Sub-Saharan Africa (all income levels)?
Offer a very short reply. 826. What is the ratio of the Aid flow (current US$) of 1961 in South Asia to that in Sub-Saharan Africa (all income levels)?
Your answer should be compact. 789.33. What is the ratio of the Aid flow (current US$) in 1962 in South Asia to that in Sub-Saharan Africa (all income levels)?
Provide a succinct answer. 93.55. What is the ratio of the Aid flow (current US$) in 1963 in South Asia to that in Sub-Saharan Africa (all income levels)?
Your answer should be compact. 339. What is the difference between the highest and the second highest Aid flow (current US$) of 1960?
Your answer should be compact. 3.87e+07. What is the difference between the highest and the second highest Aid flow (current US$) in 1961?
Keep it short and to the point. 5.86e+07. What is the difference between the highest and the second highest Aid flow (current US$) in 1962?
Make the answer very short. 4.44e+07. What is the difference between the highest and the second highest Aid flow (current US$) in 1963?
Offer a terse response. 5.01e+07. What is the difference between the highest and the lowest Aid flow (current US$) of 1960?
Ensure brevity in your answer.  5.52e+07. What is the difference between the highest and the lowest Aid flow (current US$) in 1961?
Give a very brief answer. 8.23e+07. What is the difference between the highest and the lowest Aid flow (current US$) in 1962?
Keep it short and to the point. 5.46e+07. What is the difference between the highest and the lowest Aid flow (current US$) in 1963?
Provide a short and direct response. 9.40e+07. 